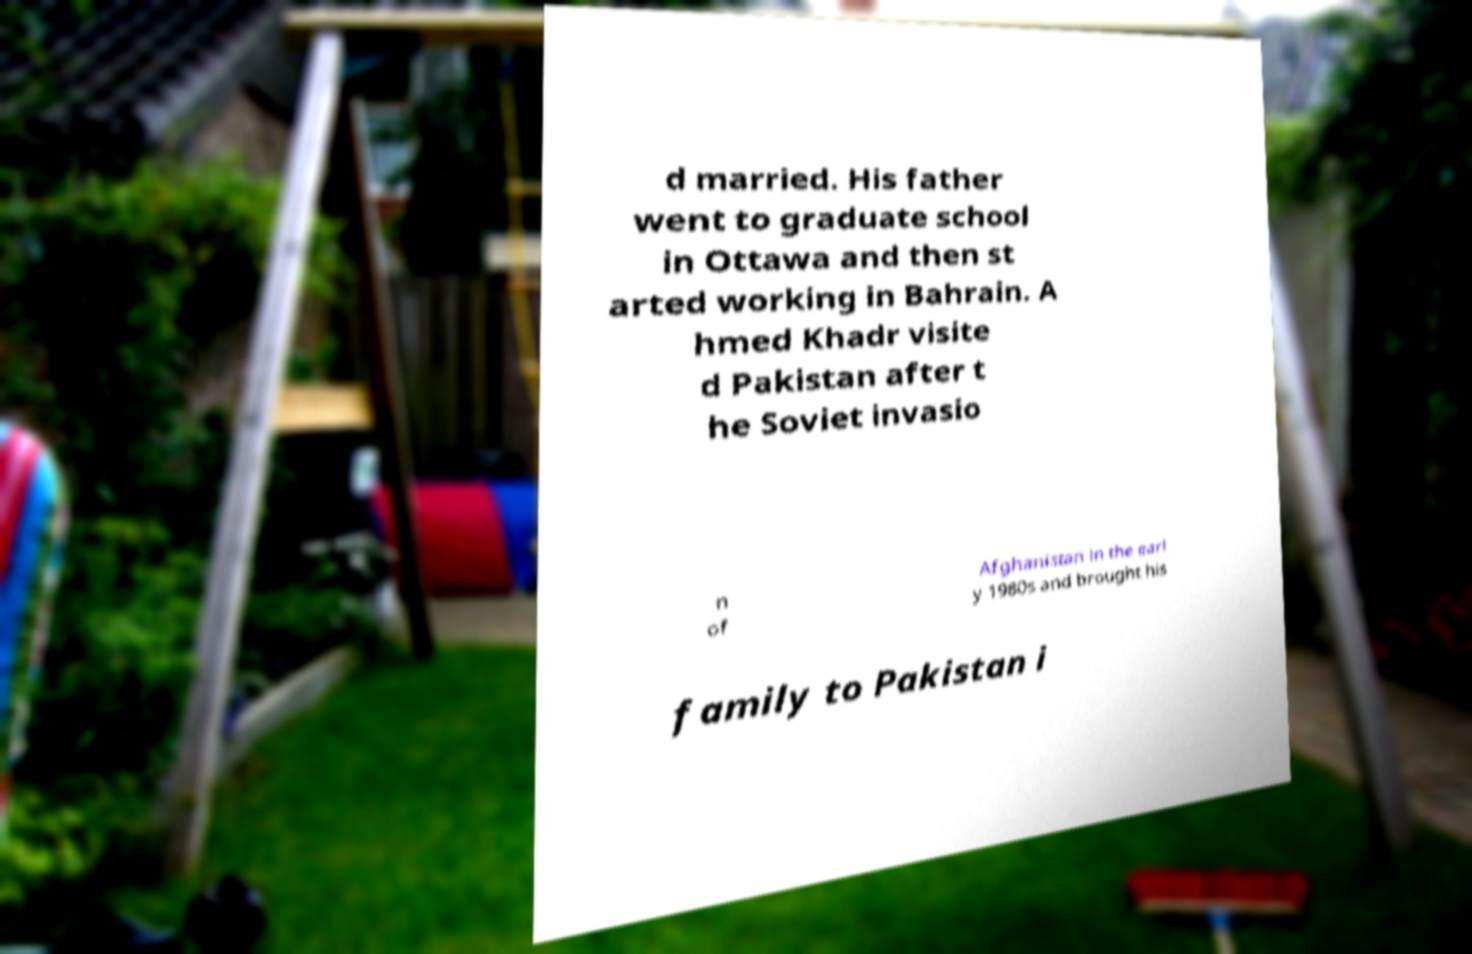What messages or text are displayed in this image? I need them in a readable, typed format. d married. His father went to graduate school in Ottawa and then st arted working in Bahrain. A hmed Khadr visite d Pakistan after t he Soviet invasio n of Afghanistan in the earl y 1980s and brought his family to Pakistan i 